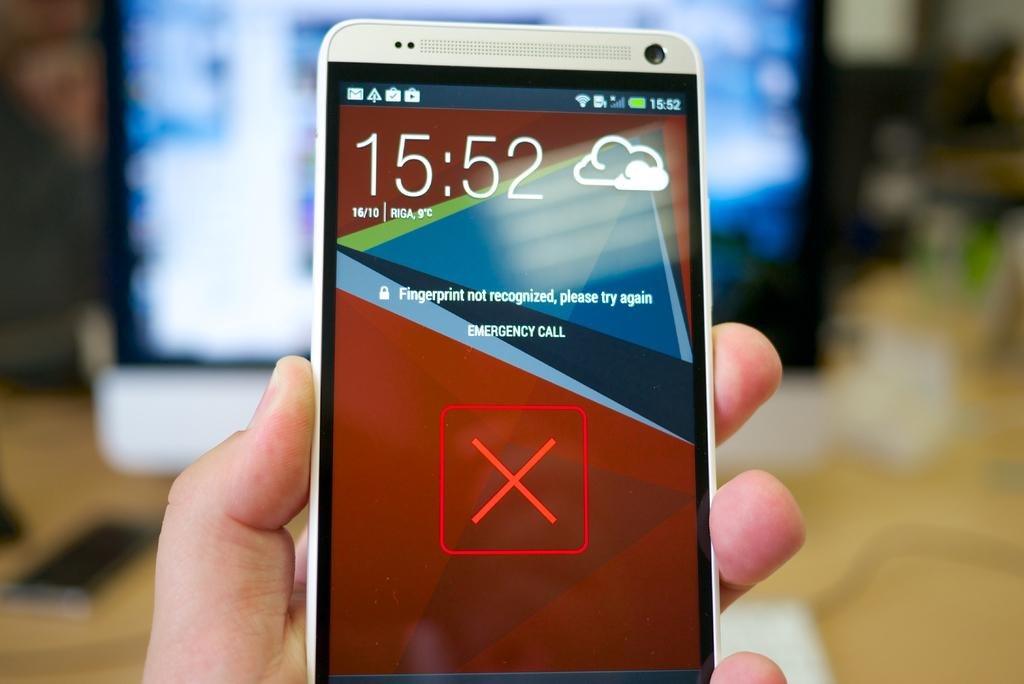What is the main subject of the image? The main subject of the image is a hand holding a mobile. Can you describe the background of the image? The background of the image is blurry. What type of magic is being performed on the person's throat in the image? There is no person's throat or magic present in the image; it only shows a hand holding a mobile. 